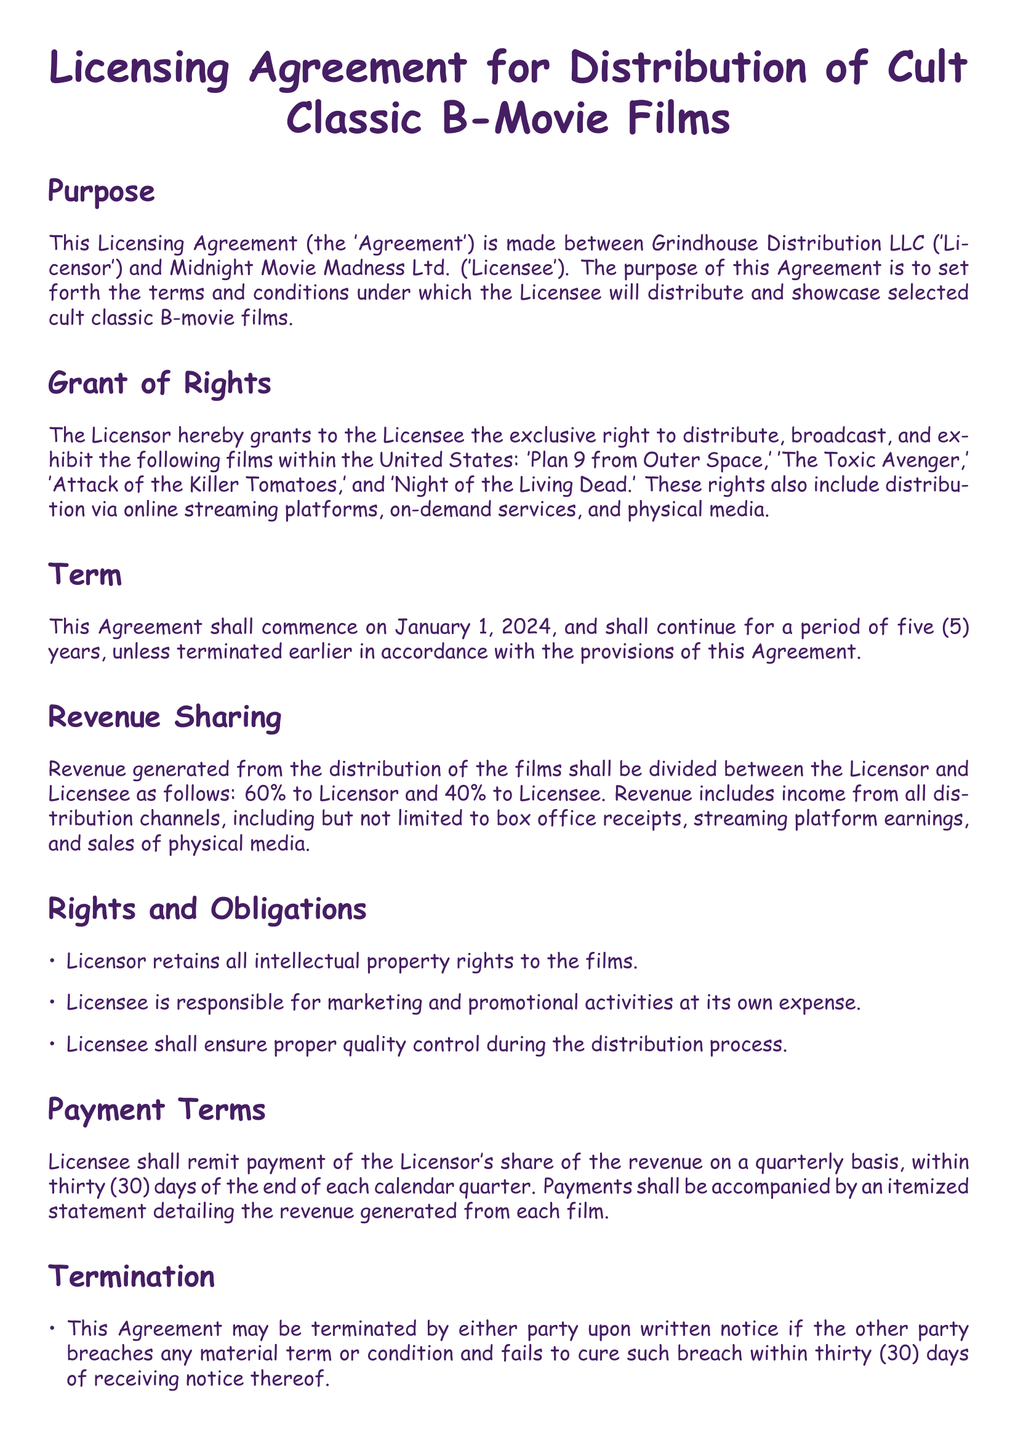What is the purpose of the Agreement? The Agreement is intended to set forth the terms and conditions under which the Licensee will distribute and showcase selected cult classic B-movie films.
Answer: set forth the terms and conditions for distribution Who are the parties involved in the Agreement? The Agreement is made between Grindhouse Distribution LLC and Midnight Movie Madness Ltd.
Answer: Grindhouse Distribution LLC and Midnight Movie Madness Ltd What is the duration of the Agreement? The Agreement commences on January 1, 2024, and continues for a period of five years unless terminated earlier.
Answer: five years What percentage of revenue goes to the Licensor? The revenue sharing stipulates that 60% of revenue generated goes to the Licensor.
Answer: 60% What are the responsibilities of the Licensee? The Licensee is responsible for marketing, promotional activities, and ensuring proper quality control during distribution.
Answer: marketing and promotional activities What happens upon termination of the Agreement? Upon termination, all distribution rights granted to Licensee shall immediately revert to Licensor.
Answer: rights revert to Licensor What is the payment frequency stipulated in the Agreement? Licensee shall remit payment of the Licensor's share of revenue on a quarterly basis.
Answer: quarterly Which law governs the Agreement? The Agreement shall be governed by the laws of the State of California.
Answer: State of California 